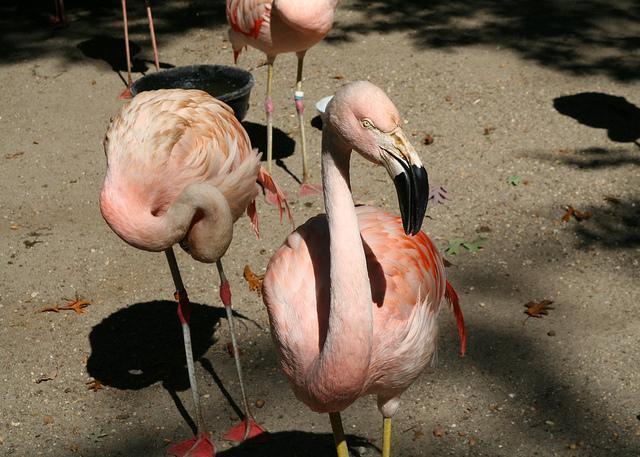What aquatic order are these birds from?
Select the accurate answer and provide explanation: 'Answer: answer
Rationale: rationale.'
Options: Phoenicopteriformes, vegaviiformes, podicipediformes, anseriformes. Answer: phoenicopteriformes.
Rationale: Several flamingos are posing in the sand. the only way to find this information is to research group. 